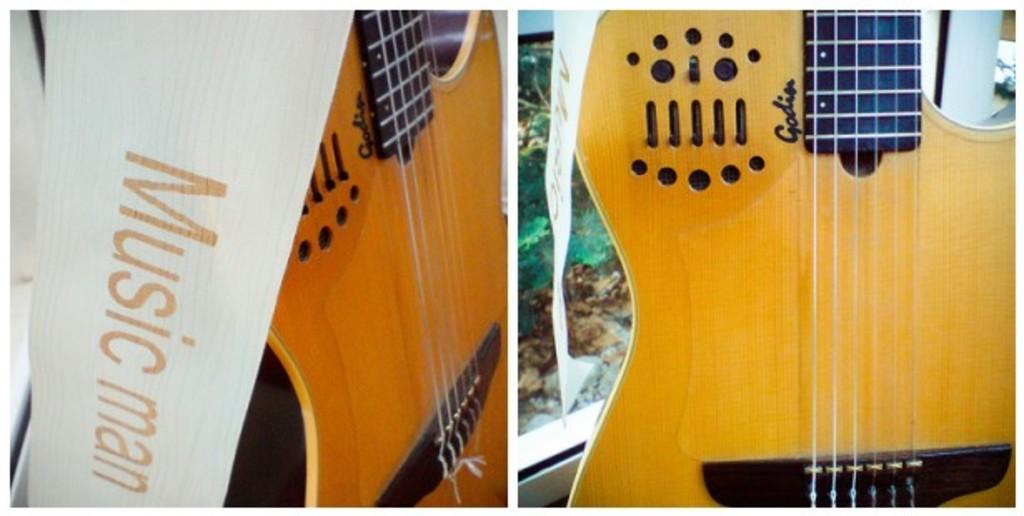What musical instruments are present in the image? There are two guitars in the image. What brand or model are the guitars? The guitars have the name "Music Man" on them. What type of cushion is used to support the guitars in the image? There is no cushion present in the image; the guitars are not shown being supported by any object. 